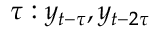Convert formula to latex. <formula><loc_0><loc_0><loc_500><loc_500>\tau \colon y _ { t - \tau } , y _ { t - 2 \tau }</formula> 